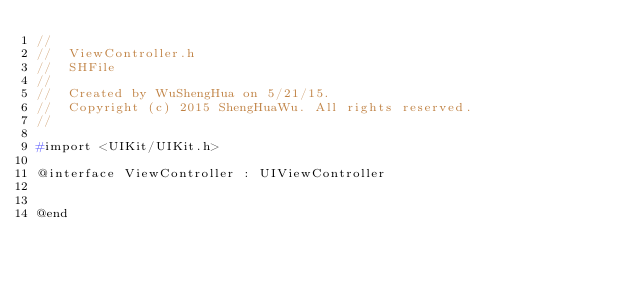<code> <loc_0><loc_0><loc_500><loc_500><_C_>//
//  ViewController.h
//  SHFile
//
//  Created by WuShengHua on 5/21/15.
//  Copyright (c) 2015 ShengHuaWu. All rights reserved.
//

#import <UIKit/UIKit.h>

@interface ViewController : UIViewController


@end

</code> 